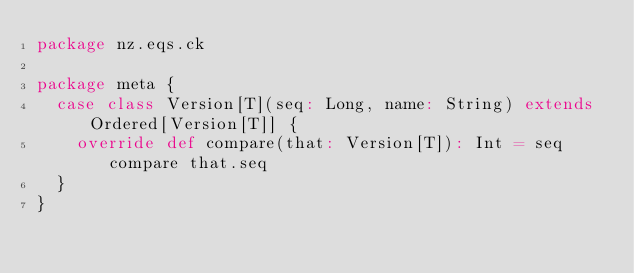<code> <loc_0><loc_0><loc_500><loc_500><_Scala_>package nz.eqs.ck

package meta {
  case class Version[T](seq: Long, name: String) extends Ordered[Version[T]] {
    override def compare(that: Version[T]): Int = seq compare that.seq
  }
}
</code> 